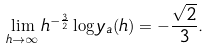<formula> <loc_0><loc_0><loc_500><loc_500>\lim _ { h \to \infty } h ^ { - { \frac { 3 } { 2 } } } \log y _ { a } ( h ) = - \frac { \sqrt { 2 } } 3 .</formula> 